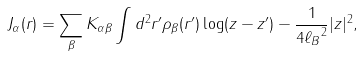Convert formula to latex. <formula><loc_0><loc_0><loc_500><loc_500>J _ { \alpha } ( { r } ) = \sum _ { \beta } K _ { \alpha \beta } \int d ^ { 2 } { r } ^ { \prime } \rho _ { \beta } ( { r } ^ { \prime } ) \log ( z - z ^ { \prime } ) - \frac { 1 } { 4 { \ell _ { B } } ^ { 2 } } | z | ^ { 2 } ,</formula> 